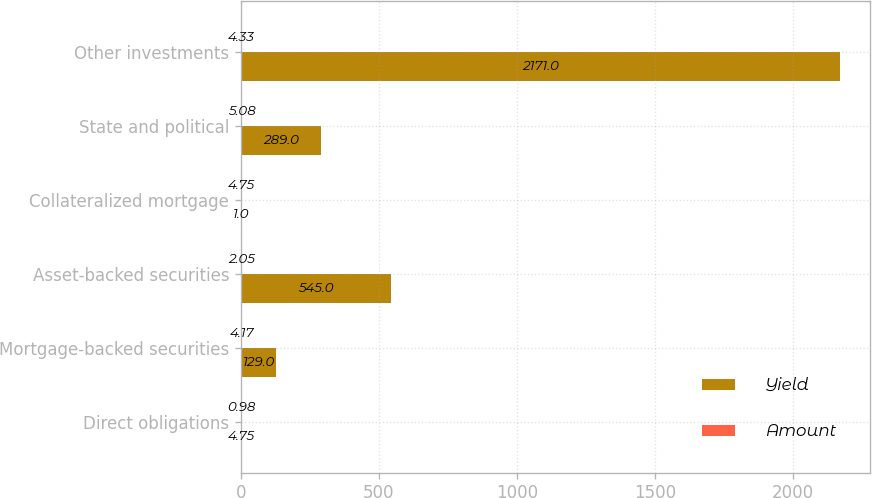Convert chart. <chart><loc_0><loc_0><loc_500><loc_500><stacked_bar_chart><ecel><fcel>Direct obligations<fcel>Mortgage-backed securities<fcel>Asset-backed securities<fcel>Collateralized mortgage<fcel>State and political<fcel>Other investments<nl><fcel>Yield<fcel>4.75<fcel>129<fcel>545<fcel>1<fcel>289<fcel>2171<nl><fcel>Amount<fcel>0.98<fcel>4.17<fcel>2.05<fcel>4.75<fcel>5.08<fcel>4.33<nl></chart> 